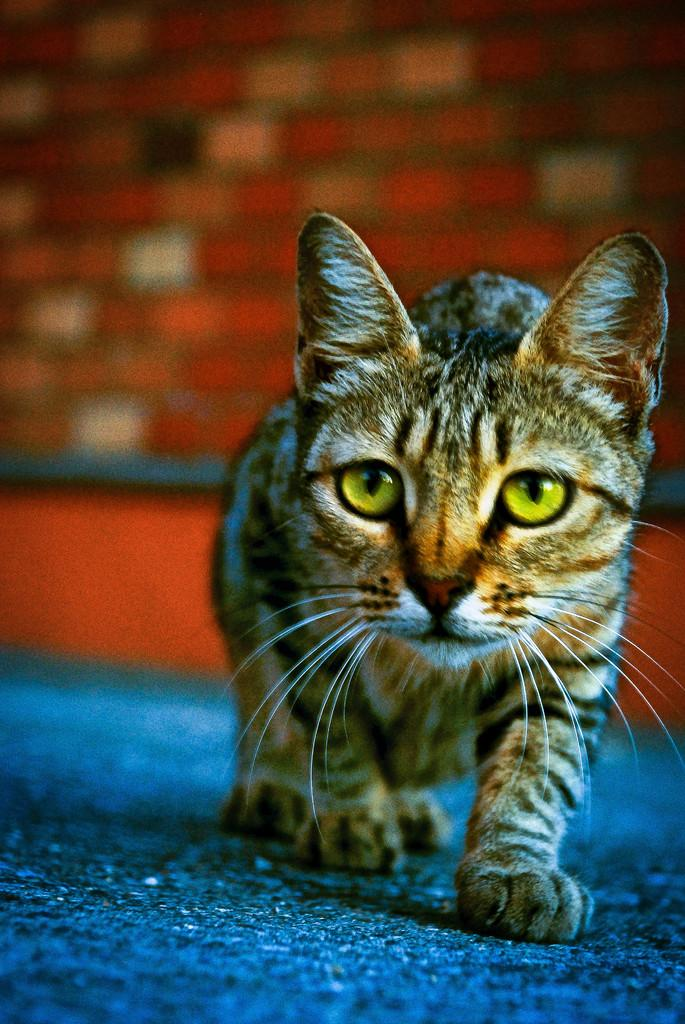What type of animal is present in the image? There is a cat in the image. What is the cat doing in the image? The cat is walking on a surface that resembles a floor. Can you describe the background of the image? The background of the image is blurred. What type of meal is being prepared in the background of the image? There is no meal preparation visible in the image; the background is blurred. How many ducks are present in the image? There are no ducks present in the image; it features a cat walking on a surface. 